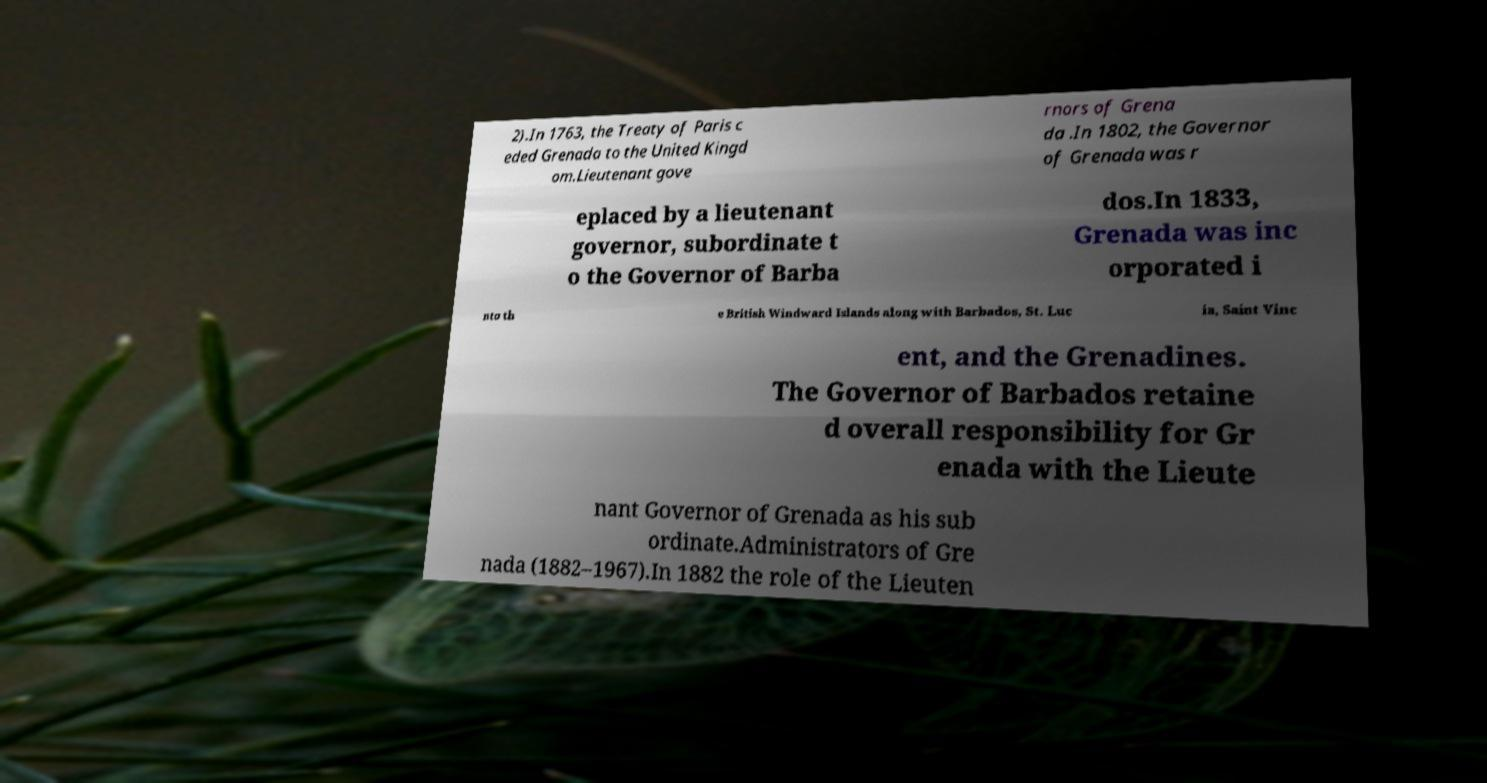Could you assist in decoding the text presented in this image and type it out clearly? 2).In 1763, the Treaty of Paris c eded Grenada to the United Kingd om.Lieutenant gove rnors of Grena da .In 1802, the Governor of Grenada was r eplaced by a lieutenant governor, subordinate t o the Governor of Barba dos.In 1833, Grenada was inc orporated i nto th e British Windward Islands along with Barbados, St. Luc ia, Saint Vinc ent, and the Grenadines. The Governor of Barbados retaine d overall responsibility for Gr enada with the Lieute nant Governor of Grenada as his sub ordinate.Administrators of Gre nada (1882–1967).In 1882 the role of the Lieuten 